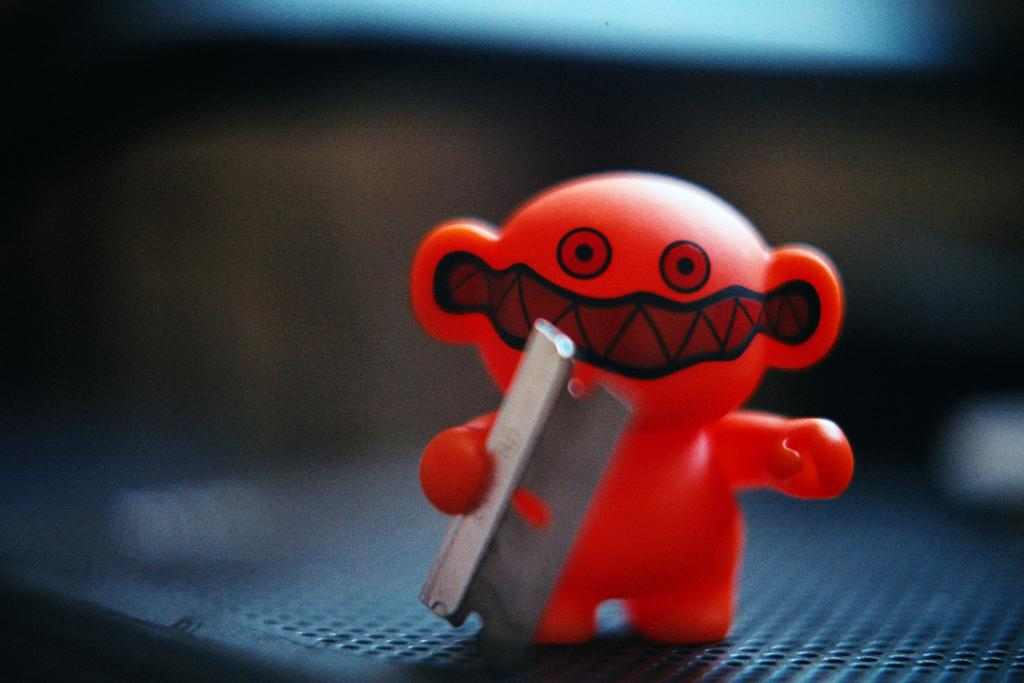What color is the toy in the image? The toy in the image is red. Where is the toy located in the image? The toy is placed on a surface. How would you describe the background of the image? The background of the image is dark and blurred completely. How many pies are on the toy in the image? There are no pies present in the image, as it features a red toy placed on a surface with a dark and blurred background. 